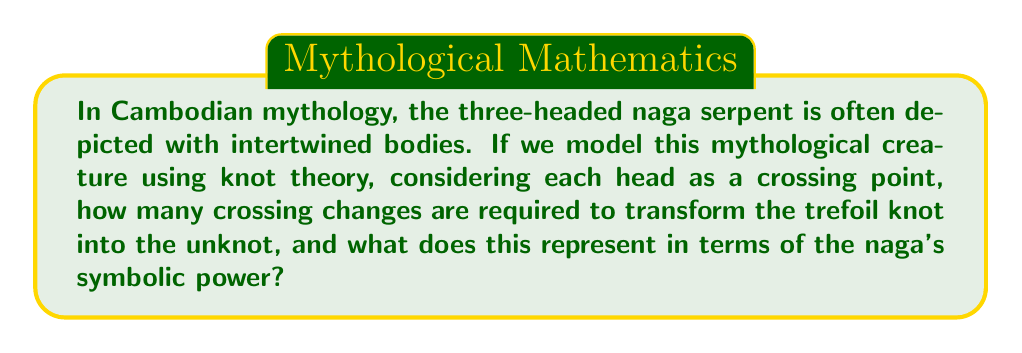Show me your answer to this math problem. Let's approach this step-by-step:

1) The trefoil knot is the simplest non-trivial knot in knot theory. It has a crossing number of 3, which aligns with the three heads of the naga serpent in Cambodian mythology.

2) In knot theory, the unknotting number of a knot is the minimum number of crossing changes required to transform the knot into the unknot (also known as the trivial knot).

3) For the trefoil knot, the unknotting number is 1. This can be proven using the following steps:

   a) The trefoil knot can be represented by the braid word $\sigma_1^3$, where $\sigma_1$ represents a positive crossing.
   
   b) The unknot can be represented by an empty braid word.
   
   c) To transform $\sigma_1^3$ into an empty word, we need to cancel out one $\sigma_1$ with a $\sigma_1^{-1}$.
   
   d) This cancellation represents one crossing change.

4) Mathematically, we can express this as:

   $$U(\text{Trefoil}) = 1$$

   Where $U(K)$ denotes the unknotting number of knot $K$.

5) In the context of Cambodian mythology, this single crossing change can be interpreted as a symbolic representation of the naga's power to transform or transcend its physical form.

6) The fact that only one change is needed could be seen as representing the potency and efficiency of the naga's mythical abilities.
Answer: 1 crossing change 